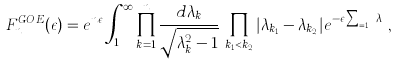<formula> <loc_0><loc_0><loc_500><loc_500>F ^ { G O E } _ { n } ( \epsilon ) = e ^ { n \epsilon } \int _ { 1 } ^ { \infty } \prod _ { k = 1 } ^ { n } \frac { d \lambda _ { k } } { \sqrt { \lambda _ { k } ^ { 2 } - 1 } } \, \prod _ { k _ { 1 } < k _ { 2 } } | \lambda _ { k _ { 1 } } - \lambda _ { k _ { 2 } } | e ^ { - \epsilon \sum _ { k = 1 } ^ { n } \lambda _ { k } } ,</formula> 